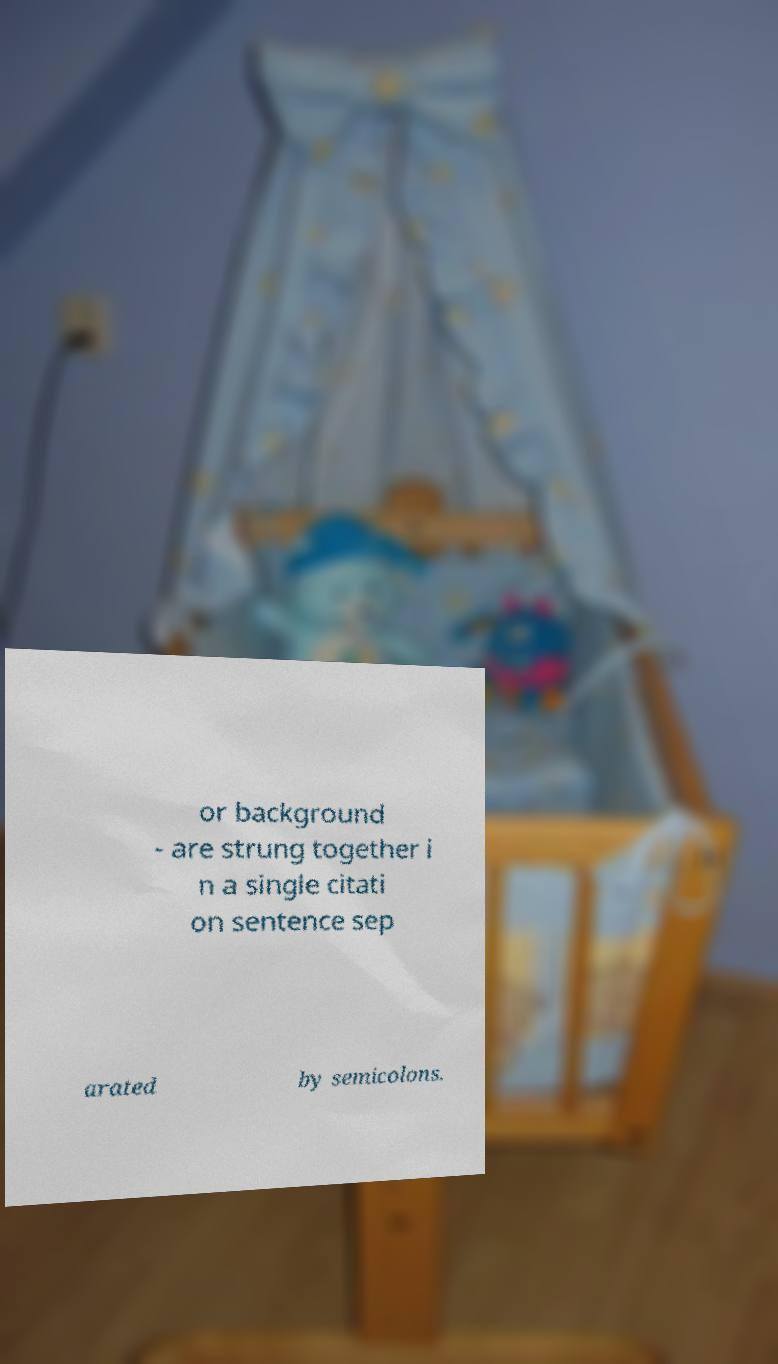Please read and relay the text visible in this image. What does it say? or background - are strung together i n a single citati on sentence sep arated by semicolons. 